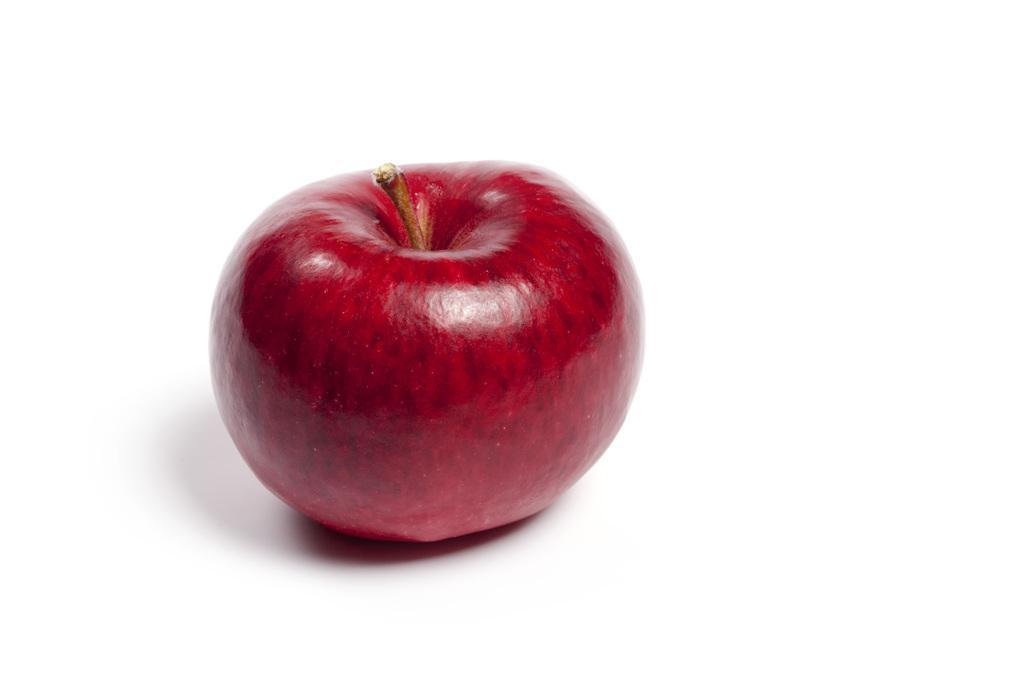Please provide a concise description of this image. In the picture we can see an apple, which is red in color placed on the white surface. 